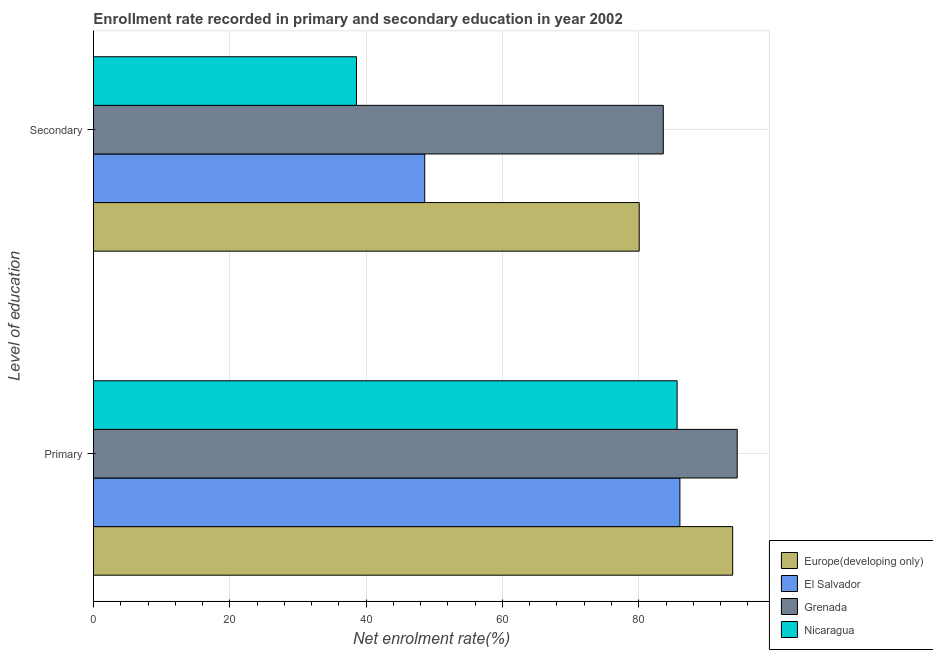Are the number of bars per tick equal to the number of legend labels?
Your response must be concise. Yes. How many bars are there on the 1st tick from the top?
Offer a terse response. 4. How many bars are there on the 1st tick from the bottom?
Make the answer very short. 4. What is the label of the 1st group of bars from the top?
Your answer should be very brief. Secondary. What is the enrollment rate in primary education in El Salvador?
Your response must be concise. 86.04. Across all countries, what is the maximum enrollment rate in secondary education?
Your answer should be very brief. 83.6. Across all countries, what is the minimum enrollment rate in primary education?
Your response must be concise. 85.63. In which country was the enrollment rate in secondary education maximum?
Provide a succinct answer. Grenada. In which country was the enrollment rate in primary education minimum?
Keep it short and to the point. Nicaragua. What is the total enrollment rate in primary education in the graph?
Provide a short and direct response. 359.89. What is the difference between the enrollment rate in primary education in Grenada and that in Europe(developing only)?
Make the answer very short. 0.67. What is the difference between the enrollment rate in secondary education in Grenada and the enrollment rate in primary education in El Salvador?
Offer a terse response. -2.44. What is the average enrollment rate in primary education per country?
Give a very brief answer. 89.97. What is the difference between the enrollment rate in secondary education and enrollment rate in primary education in Nicaragua?
Make the answer very short. -47.04. What is the ratio of the enrollment rate in primary education in Nicaragua to that in El Salvador?
Give a very brief answer. 1. What does the 2nd bar from the top in Secondary represents?
Your answer should be compact. Grenada. What does the 2nd bar from the bottom in Primary represents?
Ensure brevity in your answer.  El Salvador. How many bars are there?
Your answer should be compact. 8. What is the difference between two consecutive major ticks on the X-axis?
Ensure brevity in your answer.  20. Are the values on the major ticks of X-axis written in scientific E-notation?
Keep it short and to the point. No. Does the graph contain grids?
Give a very brief answer. Yes. Where does the legend appear in the graph?
Your answer should be compact. Bottom right. How many legend labels are there?
Offer a very short reply. 4. How are the legend labels stacked?
Provide a succinct answer. Vertical. What is the title of the graph?
Give a very brief answer. Enrollment rate recorded in primary and secondary education in year 2002. What is the label or title of the X-axis?
Give a very brief answer. Net enrolment rate(%). What is the label or title of the Y-axis?
Your answer should be compact. Level of education. What is the Net enrolment rate(%) of Europe(developing only) in Primary?
Your answer should be very brief. 93.78. What is the Net enrolment rate(%) of El Salvador in Primary?
Provide a short and direct response. 86.04. What is the Net enrolment rate(%) of Grenada in Primary?
Make the answer very short. 94.45. What is the Net enrolment rate(%) of Nicaragua in Primary?
Keep it short and to the point. 85.63. What is the Net enrolment rate(%) of Europe(developing only) in Secondary?
Your answer should be very brief. 80.07. What is the Net enrolment rate(%) of El Salvador in Secondary?
Offer a terse response. 48.6. What is the Net enrolment rate(%) in Grenada in Secondary?
Make the answer very short. 83.6. What is the Net enrolment rate(%) of Nicaragua in Secondary?
Provide a short and direct response. 38.59. Across all Level of education, what is the maximum Net enrolment rate(%) of Europe(developing only)?
Give a very brief answer. 93.78. Across all Level of education, what is the maximum Net enrolment rate(%) of El Salvador?
Keep it short and to the point. 86.04. Across all Level of education, what is the maximum Net enrolment rate(%) of Grenada?
Provide a short and direct response. 94.45. Across all Level of education, what is the maximum Net enrolment rate(%) of Nicaragua?
Provide a succinct answer. 85.63. Across all Level of education, what is the minimum Net enrolment rate(%) in Europe(developing only)?
Keep it short and to the point. 80.07. Across all Level of education, what is the minimum Net enrolment rate(%) in El Salvador?
Give a very brief answer. 48.6. Across all Level of education, what is the minimum Net enrolment rate(%) of Grenada?
Offer a terse response. 83.6. Across all Level of education, what is the minimum Net enrolment rate(%) of Nicaragua?
Provide a short and direct response. 38.59. What is the total Net enrolment rate(%) in Europe(developing only) in the graph?
Provide a short and direct response. 173.85. What is the total Net enrolment rate(%) of El Salvador in the graph?
Keep it short and to the point. 134.64. What is the total Net enrolment rate(%) of Grenada in the graph?
Ensure brevity in your answer.  178.04. What is the total Net enrolment rate(%) in Nicaragua in the graph?
Make the answer very short. 124.22. What is the difference between the Net enrolment rate(%) of Europe(developing only) in Primary and that in Secondary?
Ensure brevity in your answer.  13.71. What is the difference between the Net enrolment rate(%) in El Salvador in Primary and that in Secondary?
Offer a terse response. 37.44. What is the difference between the Net enrolment rate(%) of Grenada in Primary and that in Secondary?
Your response must be concise. 10.85. What is the difference between the Net enrolment rate(%) of Nicaragua in Primary and that in Secondary?
Your answer should be very brief. 47.04. What is the difference between the Net enrolment rate(%) in Europe(developing only) in Primary and the Net enrolment rate(%) in El Salvador in Secondary?
Offer a very short reply. 45.18. What is the difference between the Net enrolment rate(%) of Europe(developing only) in Primary and the Net enrolment rate(%) of Grenada in Secondary?
Provide a short and direct response. 10.18. What is the difference between the Net enrolment rate(%) of Europe(developing only) in Primary and the Net enrolment rate(%) of Nicaragua in Secondary?
Give a very brief answer. 55.19. What is the difference between the Net enrolment rate(%) of El Salvador in Primary and the Net enrolment rate(%) of Grenada in Secondary?
Provide a succinct answer. 2.44. What is the difference between the Net enrolment rate(%) in El Salvador in Primary and the Net enrolment rate(%) in Nicaragua in Secondary?
Your response must be concise. 47.45. What is the difference between the Net enrolment rate(%) of Grenada in Primary and the Net enrolment rate(%) of Nicaragua in Secondary?
Provide a succinct answer. 55.86. What is the average Net enrolment rate(%) of Europe(developing only) per Level of education?
Provide a succinct answer. 86.92. What is the average Net enrolment rate(%) of El Salvador per Level of education?
Provide a succinct answer. 67.32. What is the average Net enrolment rate(%) in Grenada per Level of education?
Give a very brief answer. 89.02. What is the average Net enrolment rate(%) of Nicaragua per Level of education?
Your response must be concise. 62.11. What is the difference between the Net enrolment rate(%) of Europe(developing only) and Net enrolment rate(%) of El Salvador in Primary?
Ensure brevity in your answer.  7.74. What is the difference between the Net enrolment rate(%) in Europe(developing only) and Net enrolment rate(%) in Grenada in Primary?
Ensure brevity in your answer.  -0.67. What is the difference between the Net enrolment rate(%) of Europe(developing only) and Net enrolment rate(%) of Nicaragua in Primary?
Provide a succinct answer. 8.15. What is the difference between the Net enrolment rate(%) of El Salvador and Net enrolment rate(%) of Grenada in Primary?
Ensure brevity in your answer.  -8.41. What is the difference between the Net enrolment rate(%) of El Salvador and Net enrolment rate(%) of Nicaragua in Primary?
Keep it short and to the point. 0.41. What is the difference between the Net enrolment rate(%) in Grenada and Net enrolment rate(%) in Nicaragua in Primary?
Offer a terse response. 8.82. What is the difference between the Net enrolment rate(%) of Europe(developing only) and Net enrolment rate(%) of El Salvador in Secondary?
Give a very brief answer. 31.47. What is the difference between the Net enrolment rate(%) of Europe(developing only) and Net enrolment rate(%) of Grenada in Secondary?
Make the answer very short. -3.53. What is the difference between the Net enrolment rate(%) of Europe(developing only) and Net enrolment rate(%) of Nicaragua in Secondary?
Keep it short and to the point. 41.48. What is the difference between the Net enrolment rate(%) of El Salvador and Net enrolment rate(%) of Grenada in Secondary?
Your response must be concise. -35. What is the difference between the Net enrolment rate(%) of El Salvador and Net enrolment rate(%) of Nicaragua in Secondary?
Your answer should be very brief. 10.01. What is the difference between the Net enrolment rate(%) in Grenada and Net enrolment rate(%) in Nicaragua in Secondary?
Your response must be concise. 45.01. What is the ratio of the Net enrolment rate(%) of Europe(developing only) in Primary to that in Secondary?
Make the answer very short. 1.17. What is the ratio of the Net enrolment rate(%) in El Salvador in Primary to that in Secondary?
Offer a very short reply. 1.77. What is the ratio of the Net enrolment rate(%) in Grenada in Primary to that in Secondary?
Provide a succinct answer. 1.13. What is the ratio of the Net enrolment rate(%) of Nicaragua in Primary to that in Secondary?
Offer a very short reply. 2.22. What is the difference between the highest and the second highest Net enrolment rate(%) in Europe(developing only)?
Provide a short and direct response. 13.71. What is the difference between the highest and the second highest Net enrolment rate(%) in El Salvador?
Keep it short and to the point. 37.44. What is the difference between the highest and the second highest Net enrolment rate(%) of Grenada?
Give a very brief answer. 10.85. What is the difference between the highest and the second highest Net enrolment rate(%) in Nicaragua?
Keep it short and to the point. 47.04. What is the difference between the highest and the lowest Net enrolment rate(%) of Europe(developing only)?
Offer a terse response. 13.71. What is the difference between the highest and the lowest Net enrolment rate(%) in El Salvador?
Give a very brief answer. 37.44. What is the difference between the highest and the lowest Net enrolment rate(%) in Grenada?
Make the answer very short. 10.85. What is the difference between the highest and the lowest Net enrolment rate(%) in Nicaragua?
Offer a terse response. 47.04. 